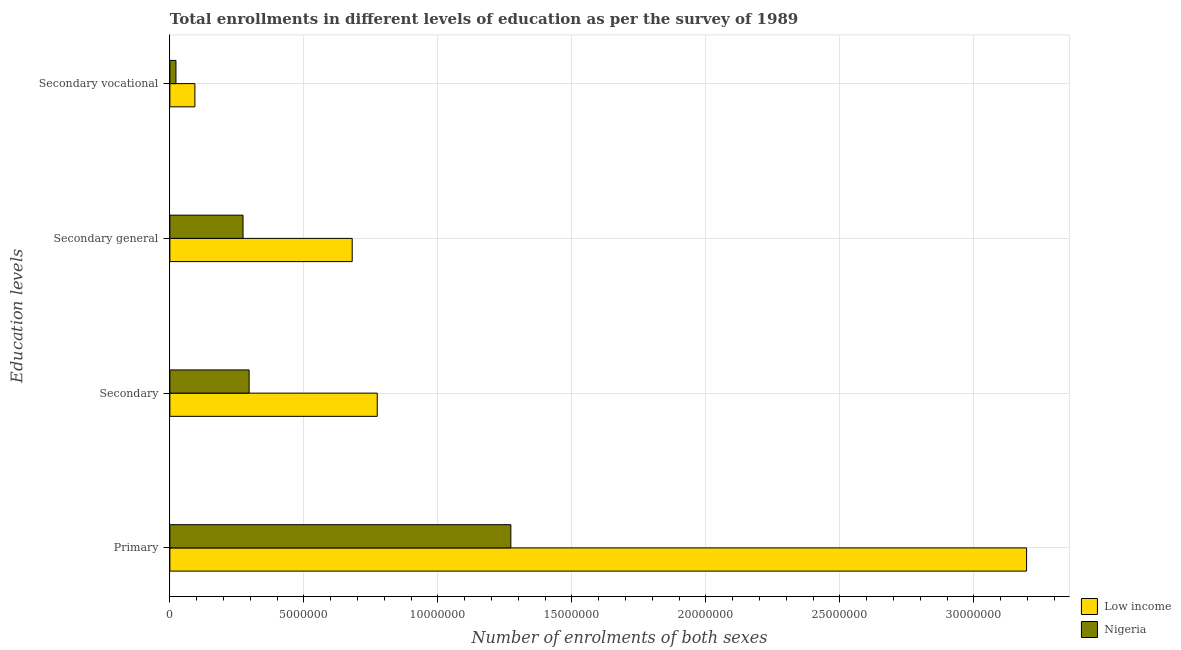Are the number of bars on each tick of the Y-axis equal?
Offer a very short reply. Yes. How many bars are there on the 1st tick from the top?
Offer a very short reply. 2. How many bars are there on the 4th tick from the bottom?
Make the answer very short. 2. What is the label of the 1st group of bars from the top?
Provide a succinct answer. Secondary vocational. What is the number of enrolments in secondary general education in Low income?
Provide a succinct answer. 6.80e+06. Across all countries, what is the maximum number of enrolments in secondary general education?
Your answer should be very brief. 6.80e+06. Across all countries, what is the minimum number of enrolments in secondary education?
Your answer should be very brief. 2.96e+06. In which country was the number of enrolments in secondary vocational education minimum?
Keep it short and to the point. Nigeria. What is the total number of enrolments in primary education in the graph?
Make the answer very short. 4.47e+07. What is the difference between the number of enrolments in secondary general education in Nigeria and that in Low income?
Offer a terse response. -4.07e+06. What is the difference between the number of enrolments in primary education in Nigeria and the number of enrolments in secondary vocational education in Low income?
Offer a terse response. 1.18e+07. What is the average number of enrolments in primary education per country?
Give a very brief answer. 2.23e+07. What is the difference between the number of enrolments in secondary vocational education and number of enrolments in secondary education in Nigeria?
Ensure brevity in your answer.  -2.73e+06. What is the ratio of the number of enrolments in secondary vocational education in Nigeria to that in Low income?
Your response must be concise. 0.24. Is the number of enrolments in secondary vocational education in Nigeria less than that in Low income?
Offer a very short reply. Yes. Is the difference between the number of enrolments in secondary vocational education in Low income and Nigeria greater than the difference between the number of enrolments in primary education in Low income and Nigeria?
Give a very brief answer. No. What is the difference between the highest and the second highest number of enrolments in secondary vocational education?
Provide a succinct answer. 7.07e+05. What is the difference between the highest and the lowest number of enrolments in secondary general education?
Provide a succinct answer. 4.07e+06. Is the sum of the number of enrolments in secondary vocational education in Nigeria and Low income greater than the maximum number of enrolments in secondary education across all countries?
Your answer should be very brief. No. Is it the case that in every country, the sum of the number of enrolments in primary education and number of enrolments in secondary vocational education is greater than the sum of number of enrolments in secondary general education and number of enrolments in secondary education?
Make the answer very short. No. What does the 1st bar from the top in Secondary represents?
Your response must be concise. Nigeria. Are all the bars in the graph horizontal?
Keep it short and to the point. Yes. What is the difference between two consecutive major ticks on the X-axis?
Give a very brief answer. 5.00e+06. Are the values on the major ticks of X-axis written in scientific E-notation?
Make the answer very short. No. Does the graph contain any zero values?
Your response must be concise. No. Does the graph contain grids?
Your response must be concise. Yes. Where does the legend appear in the graph?
Give a very brief answer. Bottom right. What is the title of the graph?
Your response must be concise. Total enrollments in different levels of education as per the survey of 1989. What is the label or title of the X-axis?
Keep it short and to the point. Number of enrolments of both sexes. What is the label or title of the Y-axis?
Keep it short and to the point. Education levels. What is the Number of enrolments of both sexes of Low income in Primary?
Your answer should be compact. 3.20e+07. What is the Number of enrolments of both sexes of Nigeria in Primary?
Provide a succinct answer. 1.27e+07. What is the Number of enrolments of both sexes of Low income in Secondary?
Provide a succinct answer. 7.74e+06. What is the Number of enrolments of both sexes in Nigeria in Secondary?
Give a very brief answer. 2.96e+06. What is the Number of enrolments of both sexes of Low income in Secondary general?
Your answer should be compact. 6.80e+06. What is the Number of enrolments of both sexes in Nigeria in Secondary general?
Keep it short and to the point. 2.73e+06. What is the Number of enrolments of both sexes in Low income in Secondary vocational?
Offer a very short reply. 9.34e+05. What is the Number of enrolments of both sexes of Nigeria in Secondary vocational?
Keep it short and to the point. 2.27e+05. Across all Education levels, what is the maximum Number of enrolments of both sexes of Low income?
Provide a short and direct response. 3.20e+07. Across all Education levels, what is the maximum Number of enrolments of both sexes of Nigeria?
Ensure brevity in your answer.  1.27e+07. Across all Education levels, what is the minimum Number of enrolments of both sexes of Low income?
Provide a succinct answer. 9.34e+05. Across all Education levels, what is the minimum Number of enrolments of both sexes of Nigeria?
Provide a short and direct response. 2.27e+05. What is the total Number of enrolments of both sexes of Low income in the graph?
Provide a succinct answer. 4.74e+07. What is the total Number of enrolments of both sexes of Nigeria in the graph?
Ensure brevity in your answer.  1.86e+07. What is the difference between the Number of enrolments of both sexes in Low income in Primary and that in Secondary?
Offer a very short reply. 2.42e+07. What is the difference between the Number of enrolments of both sexes of Nigeria in Primary and that in Secondary?
Ensure brevity in your answer.  9.76e+06. What is the difference between the Number of enrolments of both sexes of Low income in Primary and that in Secondary general?
Provide a short and direct response. 2.52e+07. What is the difference between the Number of enrolments of both sexes in Nigeria in Primary and that in Secondary general?
Provide a short and direct response. 9.99e+06. What is the difference between the Number of enrolments of both sexes in Low income in Primary and that in Secondary vocational?
Provide a short and direct response. 3.10e+07. What is the difference between the Number of enrolments of both sexes of Nigeria in Primary and that in Secondary vocational?
Ensure brevity in your answer.  1.25e+07. What is the difference between the Number of enrolments of both sexes in Low income in Secondary and that in Secondary general?
Ensure brevity in your answer.  9.34e+05. What is the difference between the Number of enrolments of both sexes of Nigeria in Secondary and that in Secondary general?
Offer a very short reply. 2.27e+05. What is the difference between the Number of enrolments of both sexes of Low income in Secondary and that in Secondary vocational?
Make the answer very short. 6.80e+06. What is the difference between the Number of enrolments of both sexes in Nigeria in Secondary and that in Secondary vocational?
Ensure brevity in your answer.  2.73e+06. What is the difference between the Number of enrolments of both sexes of Low income in Secondary general and that in Secondary vocational?
Ensure brevity in your answer.  5.87e+06. What is the difference between the Number of enrolments of both sexes of Nigeria in Secondary general and that in Secondary vocational?
Provide a succinct answer. 2.50e+06. What is the difference between the Number of enrolments of both sexes of Low income in Primary and the Number of enrolments of both sexes of Nigeria in Secondary?
Your response must be concise. 2.90e+07. What is the difference between the Number of enrolments of both sexes of Low income in Primary and the Number of enrolments of both sexes of Nigeria in Secondary general?
Your answer should be compact. 2.92e+07. What is the difference between the Number of enrolments of both sexes in Low income in Primary and the Number of enrolments of both sexes in Nigeria in Secondary vocational?
Your answer should be compact. 3.17e+07. What is the difference between the Number of enrolments of both sexes in Low income in Secondary and the Number of enrolments of both sexes in Nigeria in Secondary general?
Offer a very short reply. 5.01e+06. What is the difference between the Number of enrolments of both sexes in Low income in Secondary and the Number of enrolments of both sexes in Nigeria in Secondary vocational?
Provide a short and direct response. 7.51e+06. What is the difference between the Number of enrolments of both sexes of Low income in Secondary general and the Number of enrolments of both sexes of Nigeria in Secondary vocational?
Provide a succinct answer. 6.58e+06. What is the average Number of enrolments of both sexes of Low income per Education levels?
Your response must be concise. 1.19e+07. What is the average Number of enrolments of both sexes in Nigeria per Education levels?
Provide a short and direct response. 4.66e+06. What is the difference between the Number of enrolments of both sexes in Low income and Number of enrolments of both sexes in Nigeria in Primary?
Provide a succinct answer. 1.92e+07. What is the difference between the Number of enrolments of both sexes of Low income and Number of enrolments of both sexes of Nigeria in Secondary?
Your answer should be compact. 4.78e+06. What is the difference between the Number of enrolments of both sexes in Low income and Number of enrolments of both sexes in Nigeria in Secondary general?
Your answer should be very brief. 4.07e+06. What is the difference between the Number of enrolments of both sexes in Low income and Number of enrolments of both sexes in Nigeria in Secondary vocational?
Offer a very short reply. 7.07e+05. What is the ratio of the Number of enrolments of both sexes of Low income in Primary to that in Secondary?
Your response must be concise. 4.13. What is the ratio of the Number of enrolments of both sexes of Nigeria in Primary to that in Secondary?
Offer a very short reply. 4.3. What is the ratio of the Number of enrolments of both sexes in Low income in Primary to that in Secondary general?
Offer a terse response. 4.7. What is the ratio of the Number of enrolments of both sexes of Nigeria in Primary to that in Secondary general?
Provide a succinct answer. 4.66. What is the ratio of the Number of enrolments of both sexes in Low income in Primary to that in Secondary vocational?
Make the answer very short. 34.23. What is the ratio of the Number of enrolments of both sexes of Nigeria in Primary to that in Secondary vocational?
Provide a short and direct response. 56.08. What is the ratio of the Number of enrolments of both sexes in Low income in Secondary to that in Secondary general?
Provide a short and direct response. 1.14. What is the ratio of the Number of enrolments of both sexes of Nigeria in Secondary to that in Secondary general?
Provide a succinct answer. 1.08. What is the ratio of the Number of enrolments of both sexes in Low income in Secondary to that in Secondary vocational?
Keep it short and to the point. 8.29. What is the ratio of the Number of enrolments of both sexes in Nigeria in Secondary to that in Secondary vocational?
Give a very brief answer. 13.03. What is the ratio of the Number of enrolments of both sexes of Low income in Secondary general to that in Secondary vocational?
Provide a short and direct response. 7.29. What is the ratio of the Number of enrolments of both sexes of Nigeria in Secondary general to that in Secondary vocational?
Ensure brevity in your answer.  12.03. What is the difference between the highest and the second highest Number of enrolments of both sexes in Low income?
Keep it short and to the point. 2.42e+07. What is the difference between the highest and the second highest Number of enrolments of both sexes in Nigeria?
Your answer should be very brief. 9.76e+06. What is the difference between the highest and the lowest Number of enrolments of both sexes in Low income?
Your answer should be compact. 3.10e+07. What is the difference between the highest and the lowest Number of enrolments of both sexes in Nigeria?
Give a very brief answer. 1.25e+07. 